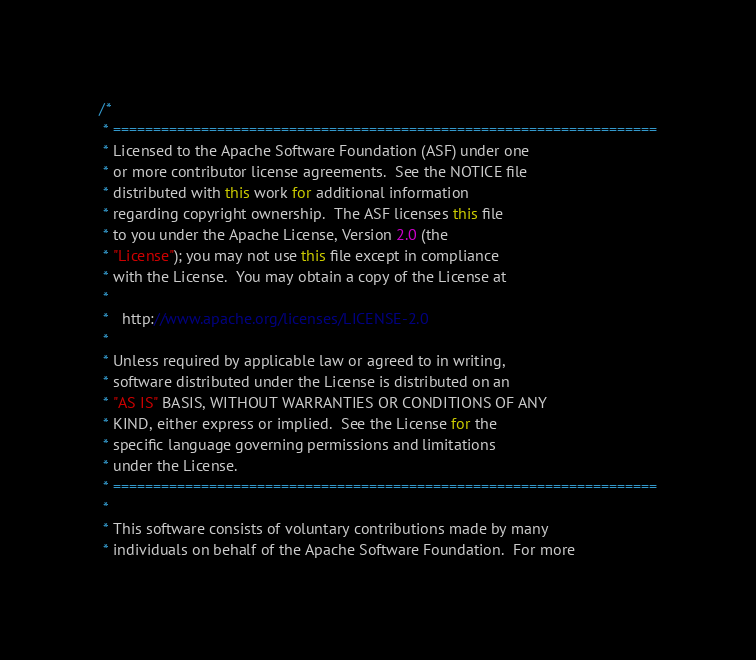Convert code to text. <code><loc_0><loc_0><loc_500><loc_500><_Java_>/*
 * ====================================================================
 * Licensed to the Apache Software Foundation (ASF) under one
 * or more contributor license agreements.  See the NOTICE file
 * distributed with this work for additional information
 * regarding copyright ownership.  The ASF licenses this file
 * to you under the Apache License, Version 2.0 (the
 * "License"); you may not use this file except in compliance
 * with the License.  You may obtain a copy of the License at
 *
 *   http://www.apache.org/licenses/LICENSE-2.0
 *
 * Unless required by applicable law or agreed to in writing,
 * software distributed under the License is distributed on an
 * "AS IS" BASIS, WITHOUT WARRANTIES OR CONDITIONS OF ANY
 * KIND, either express or implied.  See the License for the
 * specific language governing permissions and limitations
 * under the License.
 * ====================================================================
 *
 * This software consists of voluntary contributions made by many
 * individuals on behalf of the Apache Software Foundation.  For more</code> 